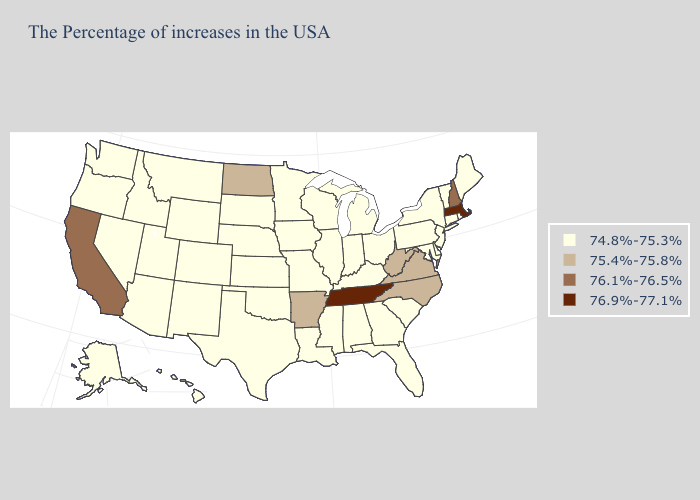Which states have the lowest value in the South?
Be succinct. Delaware, Maryland, South Carolina, Florida, Georgia, Kentucky, Alabama, Mississippi, Louisiana, Oklahoma, Texas. Name the states that have a value in the range 75.4%-75.8%?
Concise answer only. Virginia, North Carolina, West Virginia, Arkansas, North Dakota. What is the lowest value in states that border New Mexico?
Keep it brief. 74.8%-75.3%. Among the states that border Montana , does Idaho have the lowest value?
Give a very brief answer. Yes. Does Connecticut have the same value as Massachusetts?
Give a very brief answer. No. What is the lowest value in the West?
Keep it brief. 74.8%-75.3%. What is the highest value in states that border South Dakota?
Concise answer only. 75.4%-75.8%. Does Indiana have the highest value in the USA?
Give a very brief answer. No. How many symbols are there in the legend?
Be succinct. 4. What is the value of Pennsylvania?
Answer briefly. 74.8%-75.3%. Name the states that have a value in the range 75.4%-75.8%?
Write a very short answer. Virginia, North Carolina, West Virginia, Arkansas, North Dakota. What is the highest value in the USA?
Quick response, please. 76.9%-77.1%. What is the value of Montana?
Short answer required. 74.8%-75.3%. What is the value of New York?
Keep it brief. 74.8%-75.3%. 